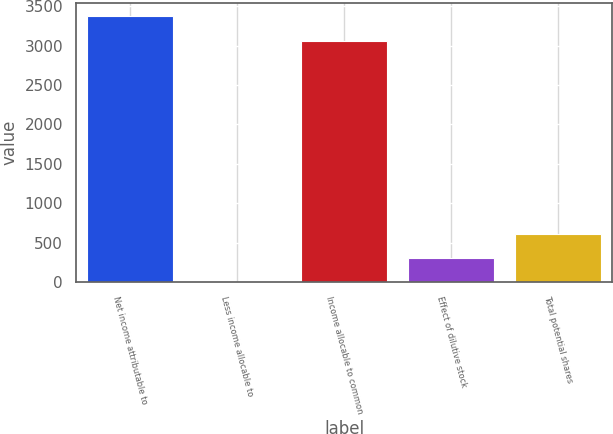Convert chart to OTSL. <chart><loc_0><loc_0><loc_500><loc_500><bar_chart><fcel>Net income attributable to<fcel>Less income allocable to<fcel>Income allocable to common<fcel>Effect of dilutive stock<fcel>Total potential shares<nl><fcel>3370.29<fcel>0.8<fcel>3063.9<fcel>307.19<fcel>613.58<nl></chart> 